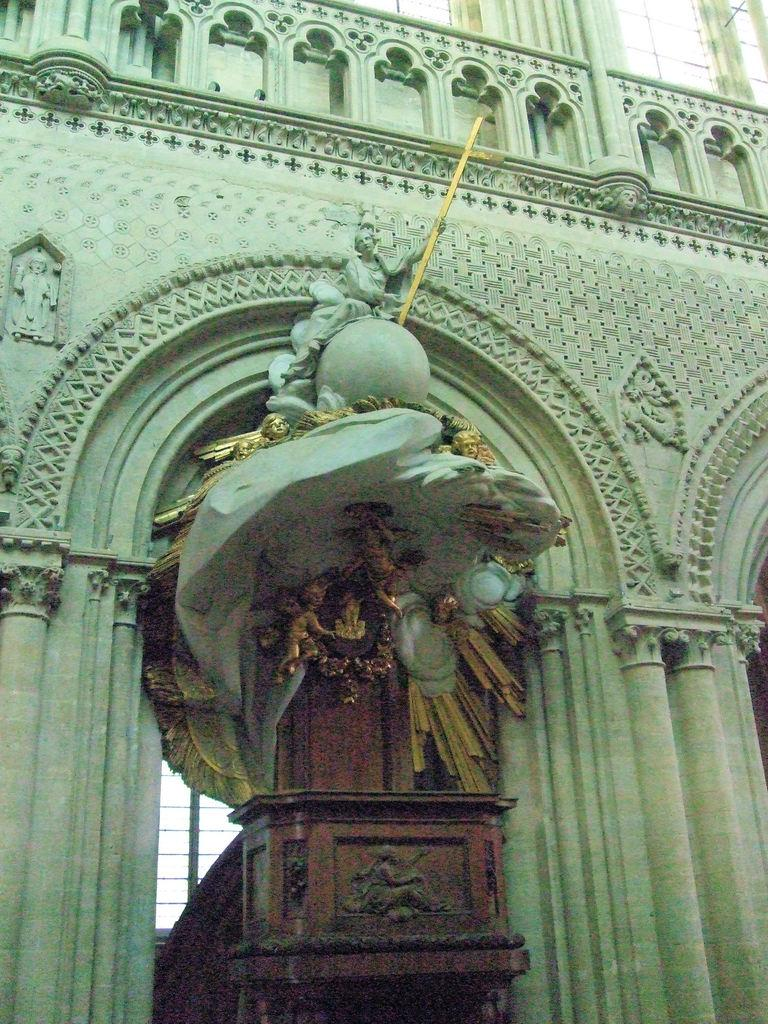What is the main subject of the image? The main subject of the image is a building. What can be seen in the foreground of the building? There is a statue in the foreground of the building. Can you describe any features of the building's back? There is a window at the back of the building. What can be seen at the top of the building? There are windows at the top of the building. What type of news is being broadcasted from the building in the image? There is no indication in the image that the building is broadcasting any news. 